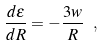Convert formula to latex. <formula><loc_0><loc_0><loc_500><loc_500>\frac { d \epsilon } { d R } = - \frac { 3 w } { R } \ ,</formula> 